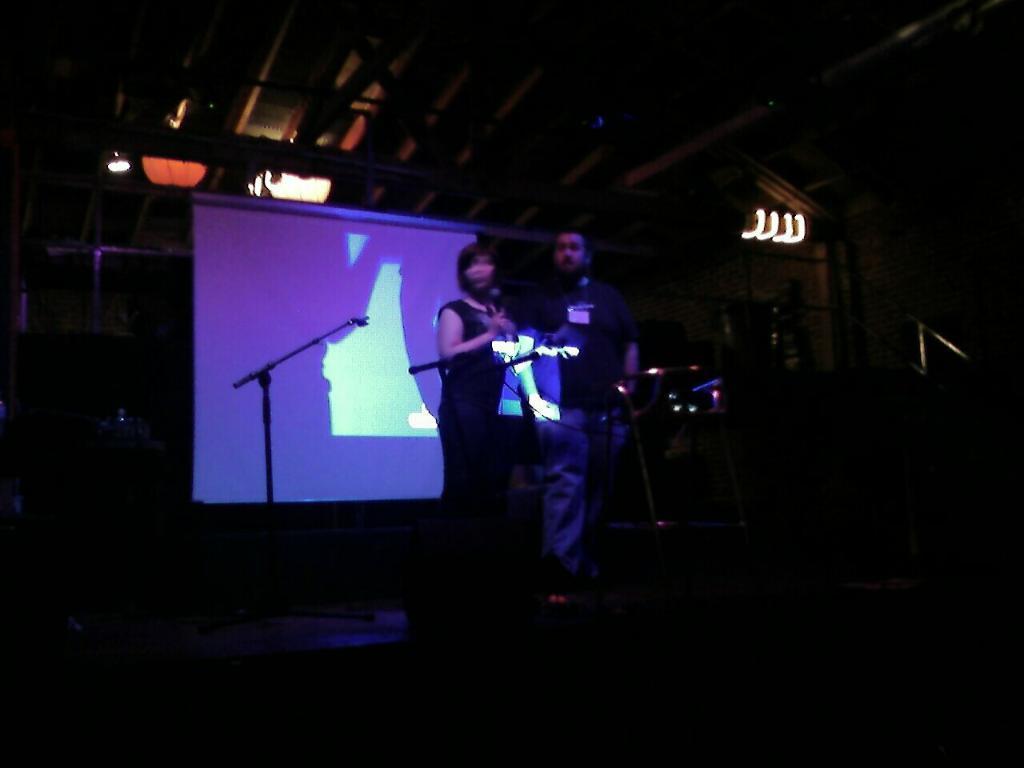In one or two sentences, can you explain what this image depicts? In this image on a stage a lady and a man are standing. In front of them there are mics. In the background there is screen. On the roof there are lights. 